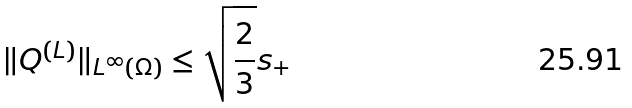<formula> <loc_0><loc_0><loc_500><loc_500>\| Q ^ { ( L ) } \| _ { L ^ { \infty } ( \Omega ) } \leq \sqrt { \frac { 2 } { 3 } } s _ { + }</formula> 